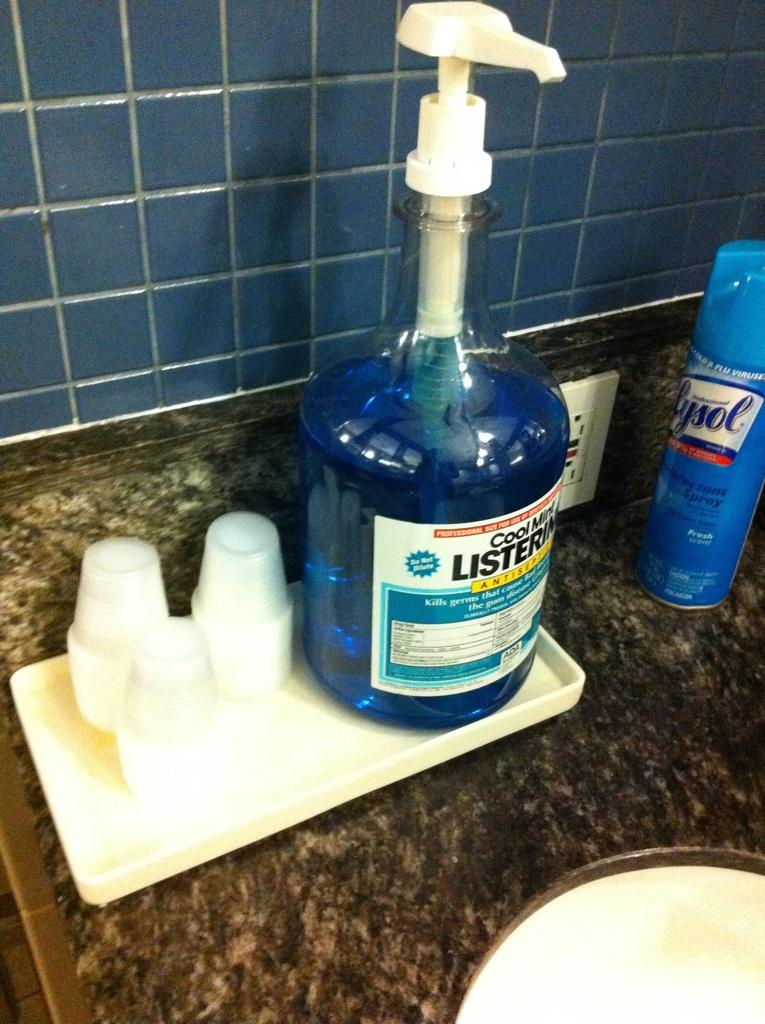What can be found in the image that is typically used for washing? There is a sink in the image that is typically used for washing. What is placed on the sink in the image? There is a tray on the sink. What items are on the tray? There are glasses and a bottle on the tray. What type of surface can be seen in the background of the image? There are tiles in the background of the image. What type of volleyball game is being played in the image? There is no volleyball game present in the image. Who is the judge presiding over the scene in the image? There is no judge present in the image. 